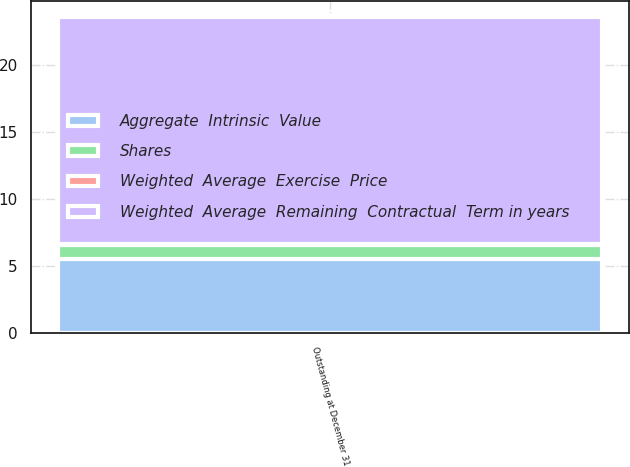<chart> <loc_0><loc_0><loc_500><loc_500><stacked_bar_chart><ecel><fcel>Outstanding at December 31<nl><fcel>Shares<fcel>1<nl><fcel>Aggregate  Intrinsic  Value<fcel>5.52<nl><fcel>Weighted  Average  Exercise  Price<fcel>0.08<nl><fcel>Weighted  Average  Remaining  Contractual  Term in years<fcel>17<nl></chart> 